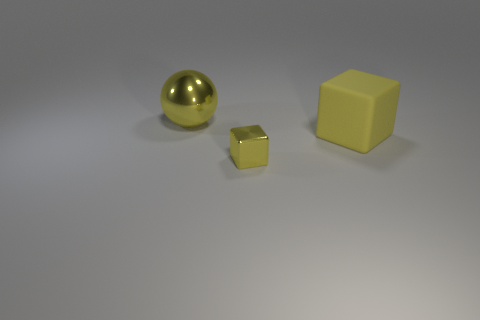Is there any other thing that is the same size as the yellow shiny block?
Provide a succinct answer. No. What shape is the big rubber object that is the same color as the shiny ball?
Make the answer very short. Cube. How many objects are metal objects that are behind the yellow metallic cube or yellow rubber blocks?
Give a very brief answer. 2. Are there fewer tiny red blocks than small cubes?
Offer a very short reply. Yes. What shape is the object that is made of the same material as the small yellow cube?
Offer a very short reply. Sphere. Are there any yellow metal things in front of the tiny object?
Your answer should be compact. No. Are there fewer yellow matte cubes on the left side of the small yellow shiny object than large rubber objects?
Keep it short and to the point. Yes. What is the material of the yellow sphere?
Provide a succinct answer. Metal. The big sphere is what color?
Your response must be concise. Yellow. What color is the object that is right of the yellow shiny sphere and behind the small yellow thing?
Make the answer very short. Yellow. 